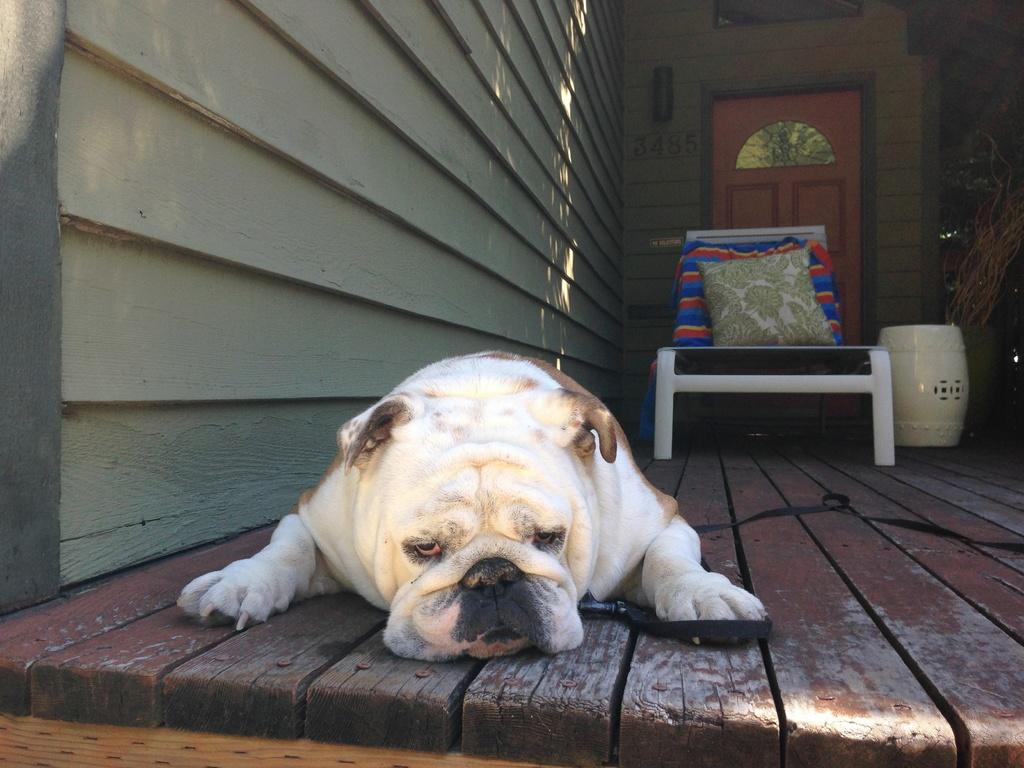What type of animal is in the image? There is a dog in the image. What furniture can be seen in the background of the image? There is a chair in the background of the image. What soft item is present in the background of the image? There is a pillow in the background of the image. What architectural feature is visible in the background of the image? There is a door in the background of the image. What type of plant is growing on the dog in the image? There is no plant growing on the dog in the image. 